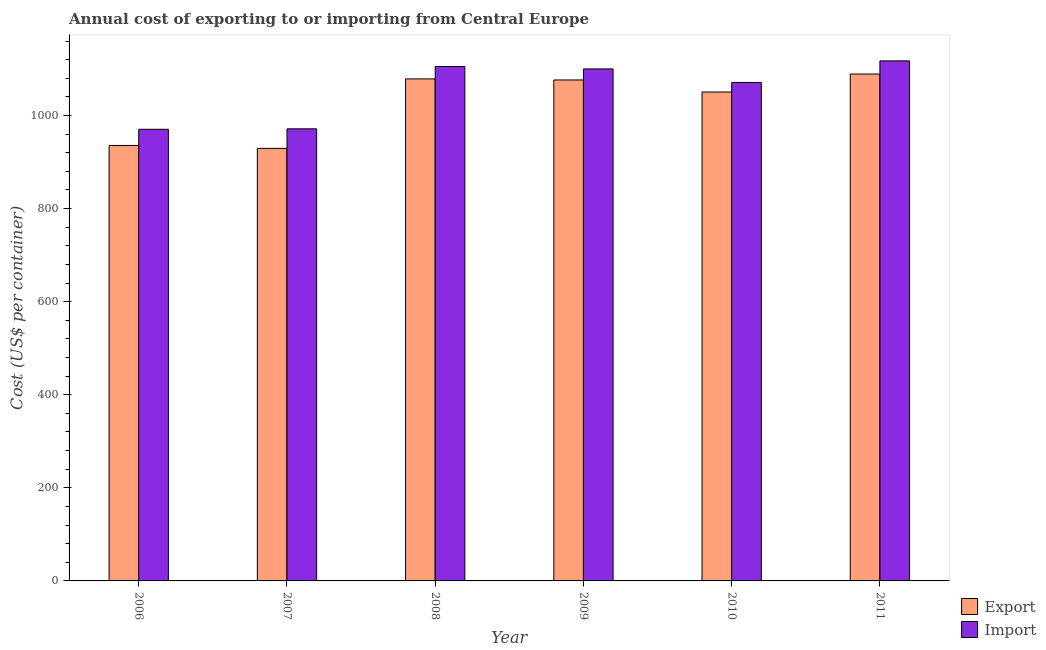Are the number of bars per tick equal to the number of legend labels?
Provide a short and direct response. Yes. Are the number of bars on each tick of the X-axis equal?
Your response must be concise. Yes. How many bars are there on the 5th tick from the right?
Keep it short and to the point. 2. In how many cases, is the number of bars for a given year not equal to the number of legend labels?
Keep it short and to the point. 0. What is the export cost in 2010?
Your answer should be compact. 1050.55. Across all years, what is the maximum import cost?
Offer a very short reply. 1117.45. Across all years, what is the minimum export cost?
Ensure brevity in your answer.  929.45. In which year was the import cost maximum?
Provide a succinct answer. 2011. What is the total import cost in the graph?
Keep it short and to the point. 6336. What is the difference between the import cost in 2009 and that in 2010?
Your answer should be very brief. 29.09. What is the difference between the export cost in 2011 and the import cost in 2006?
Give a very brief answer. 153.45. What is the average export cost per year?
Make the answer very short. 1026.68. What is the ratio of the import cost in 2007 to that in 2011?
Offer a terse response. 0.87. Is the export cost in 2007 less than that in 2009?
Offer a terse response. Yes. Is the difference between the export cost in 2007 and 2008 greater than the difference between the import cost in 2007 and 2008?
Your answer should be very brief. No. What is the difference between the highest and the second highest import cost?
Ensure brevity in your answer.  12.09. What is the difference between the highest and the lowest import cost?
Keep it short and to the point. 147. In how many years, is the import cost greater than the average import cost taken over all years?
Keep it short and to the point. 4. What does the 2nd bar from the left in 2009 represents?
Your answer should be very brief. Import. What does the 1st bar from the right in 2008 represents?
Make the answer very short. Import. How many bars are there?
Provide a succinct answer. 12. How many years are there in the graph?
Ensure brevity in your answer.  6. What is the difference between two consecutive major ticks on the Y-axis?
Give a very brief answer. 200. Does the graph contain any zero values?
Ensure brevity in your answer.  No. Where does the legend appear in the graph?
Provide a succinct answer. Bottom right. How are the legend labels stacked?
Your response must be concise. Vertical. What is the title of the graph?
Keep it short and to the point. Annual cost of exporting to or importing from Central Europe. Does "Male" appear as one of the legend labels in the graph?
Provide a short and direct response. No. What is the label or title of the Y-axis?
Your answer should be very brief. Cost (US$ per container). What is the Cost (US$ per container) of Export in 2006?
Offer a terse response. 935.73. What is the Cost (US$ per container) of Import in 2006?
Your answer should be compact. 970.45. What is the Cost (US$ per container) of Export in 2007?
Ensure brevity in your answer.  929.45. What is the Cost (US$ per container) in Import in 2007?
Give a very brief answer. 971.45. What is the Cost (US$ per container) of Export in 2008?
Ensure brevity in your answer.  1078.73. What is the Cost (US$ per container) in Import in 2008?
Your response must be concise. 1105.36. What is the Cost (US$ per container) in Export in 2009?
Your response must be concise. 1076.45. What is the Cost (US$ per container) in Import in 2009?
Offer a terse response. 1100.18. What is the Cost (US$ per container) of Export in 2010?
Offer a terse response. 1050.55. What is the Cost (US$ per container) in Import in 2010?
Make the answer very short. 1071.09. What is the Cost (US$ per container) of Export in 2011?
Offer a terse response. 1089.18. What is the Cost (US$ per container) in Import in 2011?
Offer a terse response. 1117.45. Across all years, what is the maximum Cost (US$ per container) of Export?
Offer a very short reply. 1089.18. Across all years, what is the maximum Cost (US$ per container) in Import?
Make the answer very short. 1117.45. Across all years, what is the minimum Cost (US$ per container) of Export?
Your answer should be very brief. 929.45. Across all years, what is the minimum Cost (US$ per container) of Import?
Your answer should be compact. 970.45. What is the total Cost (US$ per container) in Export in the graph?
Your response must be concise. 6160.09. What is the total Cost (US$ per container) in Import in the graph?
Your answer should be very brief. 6336. What is the difference between the Cost (US$ per container) of Export in 2006 and that in 2007?
Offer a terse response. 6.27. What is the difference between the Cost (US$ per container) in Export in 2006 and that in 2008?
Offer a very short reply. -143. What is the difference between the Cost (US$ per container) of Import in 2006 and that in 2008?
Keep it short and to the point. -134.91. What is the difference between the Cost (US$ per container) in Export in 2006 and that in 2009?
Your answer should be very brief. -140.73. What is the difference between the Cost (US$ per container) of Import in 2006 and that in 2009?
Give a very brief answer. -129.73. What is the difference between the Cost (US$ per container) in Export in 2006 and that in 2010?
Your answer should be compact. -114.82. What is the difference between the Cost (US$ per container) of Import in 2006 and that in 2010?
Offer a terse response. -100.64. What is the difference between the Cost (US$ per container) in Export in 2006 and that in 2011?
Your response must be concise. -153.45. What is the difference between the Cost (US$ per container) of Import in 2006 and that in 2011?
Offer a very short reply. -147. What is the difference between the Cost (US$ per container) of Export in 2007 and that in 2008?
Your answer should be compact. -149.27. What is the difference between the Cost (US$ per container) of Import in 2007 and that in 2008?
Keep it short and to the point. -133.91. What is the difference between the Cost (US$ per container) of Export in 2007 and that in 2009?
Your answer should be very brief. -147. What is the difference between the Cost (US$ per container) in Import in 2007 and that in 2009?
Your answer should be very brief. -128.73. What is the difference between the Cost (US$ per container) in Export in 2007 and that in 2010?
Your response must be concise. -121.09. What is the difference between the Cost (US$ per container) in Import in 2007 and that in 2010?
Make the answer very short. -99.64. What is the difference between the Cost (US$ per container) in Export in 2007 and that in 2011?
Your answer should be very brief. -159.73. What is the difference between the Cost (US$ per container) in Import in 2007 and that in 2011?
Provide a short and direct response. -146. What is the difference between the Cost (US$ per container) in Export in 2008 and that in 2009?
Give a very brief answer. 2.27. What is the difference between the Cost (US$ per container) of Import in 2008 and that in 2009?
Your answer should be compact. 5.18. What is the difference between the Cost (US$ per container) in Export in 2008 and that in 2010?
Offer a terse response. 28.18. What is the difference between the Cost (US$ per container) of Import in 2008 and that in 2010?
Make the answer very short. 34.27. What is the difference between the Cost (US$ per container) of Export in 2008 and that in 2011?
Your answer should be compact. -10.45. What is the difference between the Cost (US$ per container) of Import in 2008 and that in 2011?
Your response must be concise. -12.09. What is the difference between the Cost (US$ per container) of Export in 2009 and that in 2010?
Your answer should be very brief. 25.91. What is the difference between the Cost (US$ per container) of Import in 2009 and that in 2010?
Ensure brevity in your answer.  29.09. What is the difference between the Cost (US$ per container) in Export in 2009 and that in 2011?
Your answer should be very brief. -12.73. What is the difference between the Cost (US$ per container) in Import in 2009 and that in 2011?
Make the answer very short. -17.27. What is the difference between the Cost (US$ per container) in Export in 2010 and that in 2011?
Your response must be concise. -38.64. What is the difference between the Cost (US$ per container) in Import in 2010 and that in 2011?
Offer a terse response. -46.36. What is the difference between the Cost (US$ per container) in Export in 2006 and the Cost (US$ per container) in Import in 2007?
Provide a short and direct response. -35.73. What is the difference between the Cost (US$ per container) in Export in 2006 and the Cost (US$ per container) in Import in 2008?
Your answer should be very brief. -169.64. What is the difference between the Cost (US$ per container) of Export in 2006 and the Cost (US$ per container) of Import in 2009?
Give a very brief answer. -164.45. What is the difference between the Cost (US$ per container) of Export in 2006 and the Cost (US$ per container) of Import in 2010?
Provide a short and direct response. -135.36. What is the difference between the Cost (US$ per container) in Export in 2006 and the Cost (US$ per container) in Import in 2011?
Keep it short and to the point. -181.73. What is the difference between the Cost (US$ per container) in Export in 2007 and the Cost (US$ per container) in Import in 2008?
Ensure brevity in your answer.  -175.91. What is the difference between the Cost (US$ per container) in Export in 2007 and the Cost (US$ per container) in Import in 2009?
Your answer should be very brief. -170.73. What is the difference between the Cost (US$ per container) in Export in 2007 and the Cost (US$ per container) in Import in 2010?
Your response must be concise. -141.64. What is the difference between the Cost (US$ per container) of Export in 2007 and the Cost (US$ per container) of Import in 2011?
Your answer should be compact. -188. What is the difference between the Cost (US$ per container) in Export in 2008 and the Cost (US$ per container) in Import in 2009?
Provide a succinct answer. -21.45. What is the difference between the Cost (US$ per container) of Export in 2008 and the Cost (US$ per container) of Import in 2010?
Make the answer very short. 7.64. What is the difference between the Cost (US$ per container) of Export in 2008 and the Cost (US$ per container) of Import in 2011?
Offer a very short reply. -38.73. What is the difference between the Cost (US$ per container) of Export in 2009 and the Cost (US$ per container) of Import in 2010?
Your answer should be very brief. 5.36. What is the difference between the Cost (US$ per container) in Export in 2009 and the Cost (US$ per container) in Import in 2011?
Provide a succinct answer. -41. What is the difference between the Cost (US$ per container) in Export in 2010 and the Cost (US$ per container) in Import in 2011?
Give a very brief answer. -66.91. What is the average Cost (US$ per container) of Export per year?
Give a very brief answer. 1026.68. What is the average Cost (US$ per container) of Import per year?
Give a very brief answer. 1056. In the year 2006, what is the difference between the Cost (US$ per container) of Export and Cost (US$ per container) of Import?
Your answer should be very brief. -34.73. In the year 2007, what is the difference between the Cost (US$ per container) in Export and Cost (US$ per container) in Import?
Provide a short and direct response. -42. In the year 2008, what is the difference between the Cost (US$ per container) of Export and Cost (US$ per container) of Import?
Offer a terse response. -26.64. In the year 2009, what is the difference between the Cost (US$ per container) of Export and Cost (US$ per container) of Import?
Keep it short and to the point. -23.73. In the year 2010, what is the difference between the Cost (US$ per container) in Export and Cost (US$ per container) in Import?
Your response must be concise. -20.55. In the year 2011, what is the difference between the Cost (US$ per container) in Export and Cost (US$ per container) in Import?
Your response must be concise. -28.27. What is the ratio of the Cost (US$ per container) in Import in 2006 to that in 2007?
Make the answer very short. 1. What is the ratio of the Cost (US$ per container) in Export in 2006 to that in 2008?
Keep it short and to the point. 0.87. What is the ratio of the Cost (US$ per container) of Import in 2006 to that in 2008?
Offer a terse response. 0.88. What is the ratio of the Cost (US$ per container) of Export in 2006 to that in 2009?
Offer a very short reply. 0.87. What is the ratio of the Cost (US$ per container) in Import in 2006 to that in 2009?
Keep it short and to the point. 0.88. What is the ratio of the Cost (US$ per container) in Export in 2006 to that in 2010?
Make the answer very short. 0.89. What is the ratio of the Cost (US$ per container) in Import in 2006 to that in 2010?
Offer a terse response. 0.91. What is the ratio of the Cost (US$ per container) in Export in 2006 to that in 2011?
Keep it short and to the point. 0.86. What is the ratio of the Cost (US$ per container) of Import in 2006 to that in 2011?
Make the answer very short. 0.87. What is the ratio of the Cost (US$ per container) in Export in 2007 to that in 2008?
Offer a very short reply. 0.86. What is the ratio of the Cost (US$ per container) of Import in 2007 to that in 2008?
Keep it short and to the point. 0.88. What is the ratio of the Cost (US$ per container) of Export in 2007 to that in 2009?
Make the answer very short. 0.86. What is the ratio of the Cost (US$ per container) of Import in 2007 to that in 2009?
Give a very brief answer. 0.88. What is the ratio of the Cost (US$ per container) of Export in 2007 to that in 2010?
Keep it short and to the point. 0.88. What is the ratio of the Cost (US$ per container) in Import in 2007 to that in 2010?
Offer a terse response. 0.91. What is the ratio of the Cost (US$ per container) of Export in 2007 to that in 2011?
Provide a short and direct response. 0.85. What is the ratio of the Cost (US$ per container) of Import in 2007 to that in 2011?
Offer a very short reply. 0.87. What is the ratio of the Cost (US$ per container) in Import in 2008 to that in 2009?
Offer a very short reply. 1. What is the ratio of the Cost (US$ per container) in Export in 2008 to that in 2010?
Keep it short and to the point. 1.03. What is the ratio of the Cost (US$ per container) of Import in 2008 to that in 2010?
Your answer should be compact. 1.03. What is the ratio of the Cost (US$ per container) of Import in 2008 to that in 2011?
Offer a terse response. 0.99. What is the ratio of the Cost (US$ per container) in Export in 2009 to that in 2010?
Make the answer very short. 1.02. What is the ratio of the Cost (US$ per container) in Import in 2009 to that in 2010?
Offer a very short reply. 1.03. What is the ratio of the Cost (US$ per container) of Export in 2009 to that in 2011?
Offer a terse response. 0.99. What is the ratio of the Cost (US$ per container) in Import in 2009 to that in 2011?
Offer a very short reply. 0.98. What is the ratio of the Cost (US$ per container) in Export in 2010 to that in 2011?
Keep it short and to the point. 0.96. What is the ratio of the Cost (US$ per container) of Import in 2010 to that in 2011?
Provide a short and direct response. 0.96. What is the difference between the highest and the second highest Cost (US$ per container) in Export?
Your response must be concise. 10.45. What is the difference between the highest and the second highest Cost (US$ per container) in Import?
Offer a very short reply. 12.09. What is the difference between the highest and the lowest Cost (US$ per container) in Export?
Offer a terse response. 159.73. What is the difference between the highest and the lowest Cost (US$ per container) in Import?
Keep it short and to the point. 147. 